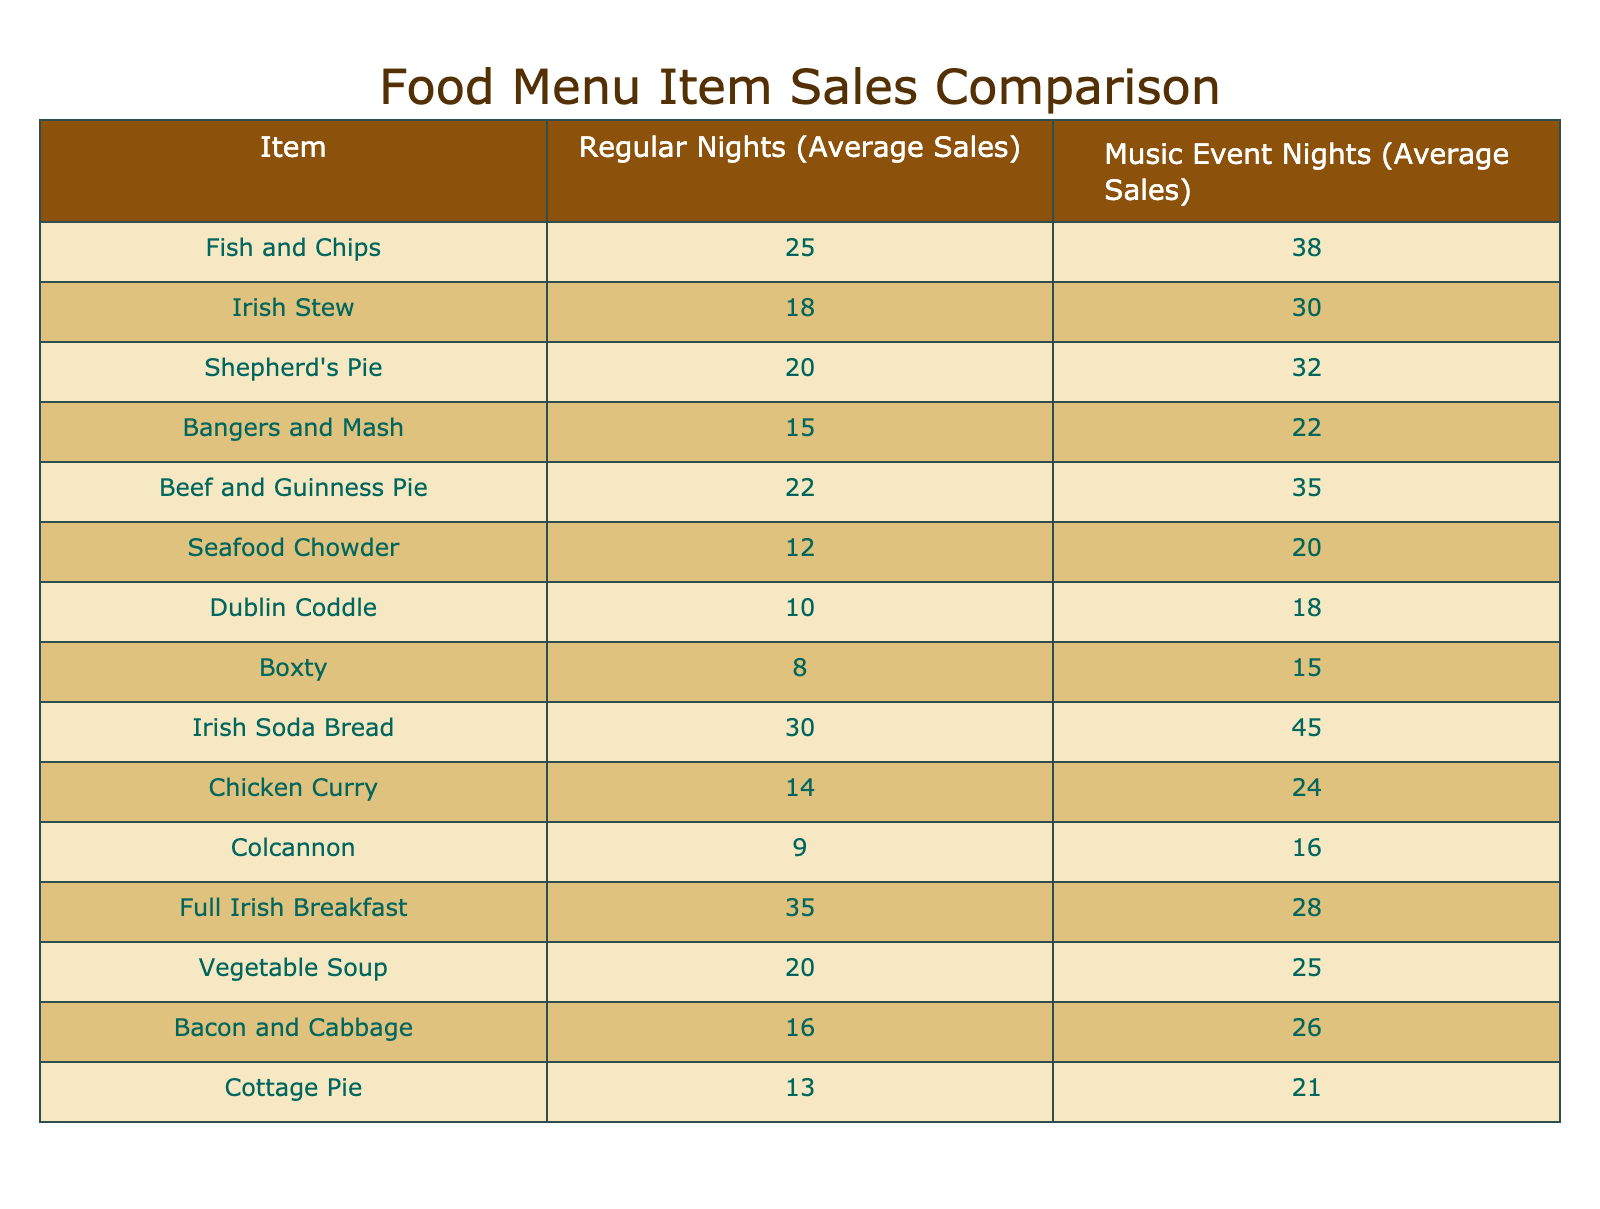What is the average sales for Irish Stew on music event nights? The table shows that the average sales for Irish Stew during music event nights is 30.
Answer: 30 Which menu item has the highest average sales on regular nights? By comparing the average sales on regular nights, Full Irish Breakfast has the highest sales at 35.
Answer: Full Irish Breakfast What is the difference in sales for Beef and Guinness Pie between regular nights and music event nights? For Beef and Guinness Pie, the average sales on regular nights is 22 and on music event nights is 35. The difference is 35 - 22 = 13.
Answer: 13 Is the average sales for Seafood Chowder higher on music event nights compared to Dublin Coddle? The average sales for Seafood Chowder on music event nights is 20, while for Dublin Coddle it is 18. Since 20 is greater than 18, the statement is true.
Answer: Yes What is the total average sales for the top three menu items on music event nights? The top three menu items by sales on music event nights are Irish Soda Bread (45), Beef and Guinness Pie (35), and Shepherd's Pie (32). Summing them up gives 45 + 35 + 32 = 112.
Answer: 112 How many items have higher sales during music event nights compared to regular nights? By examining each pair of sales, the items with higher sales on music event nights are Fish and Chips, Irish Stew, Shepherd's Pie, Beef and Guinness Pie, Irish Soda Bread, Chicken Curry, and Bacon and Cabbage. There are 7 items in total.
Answer: 7 What is the average sales for Chicken Curry on regular nights? The table shows that the average sales for Chicken Curry during regular nights is 14.
Answer: 14 Which food item has the least difference in sales between regular nights and music event nights? The sales differences for each item show that the smallest difference is for Full Irish Breakfast, with only 7 less sales on music event nights (35 on regular nights vs. 28 on music event nights).
Answer: Full Irish Breakfast Which item shows the least sales overall during regular nights? The table shows that the item with the least sales during regular nights is Boxty, with average sales of 8.
Answer: Boxty 